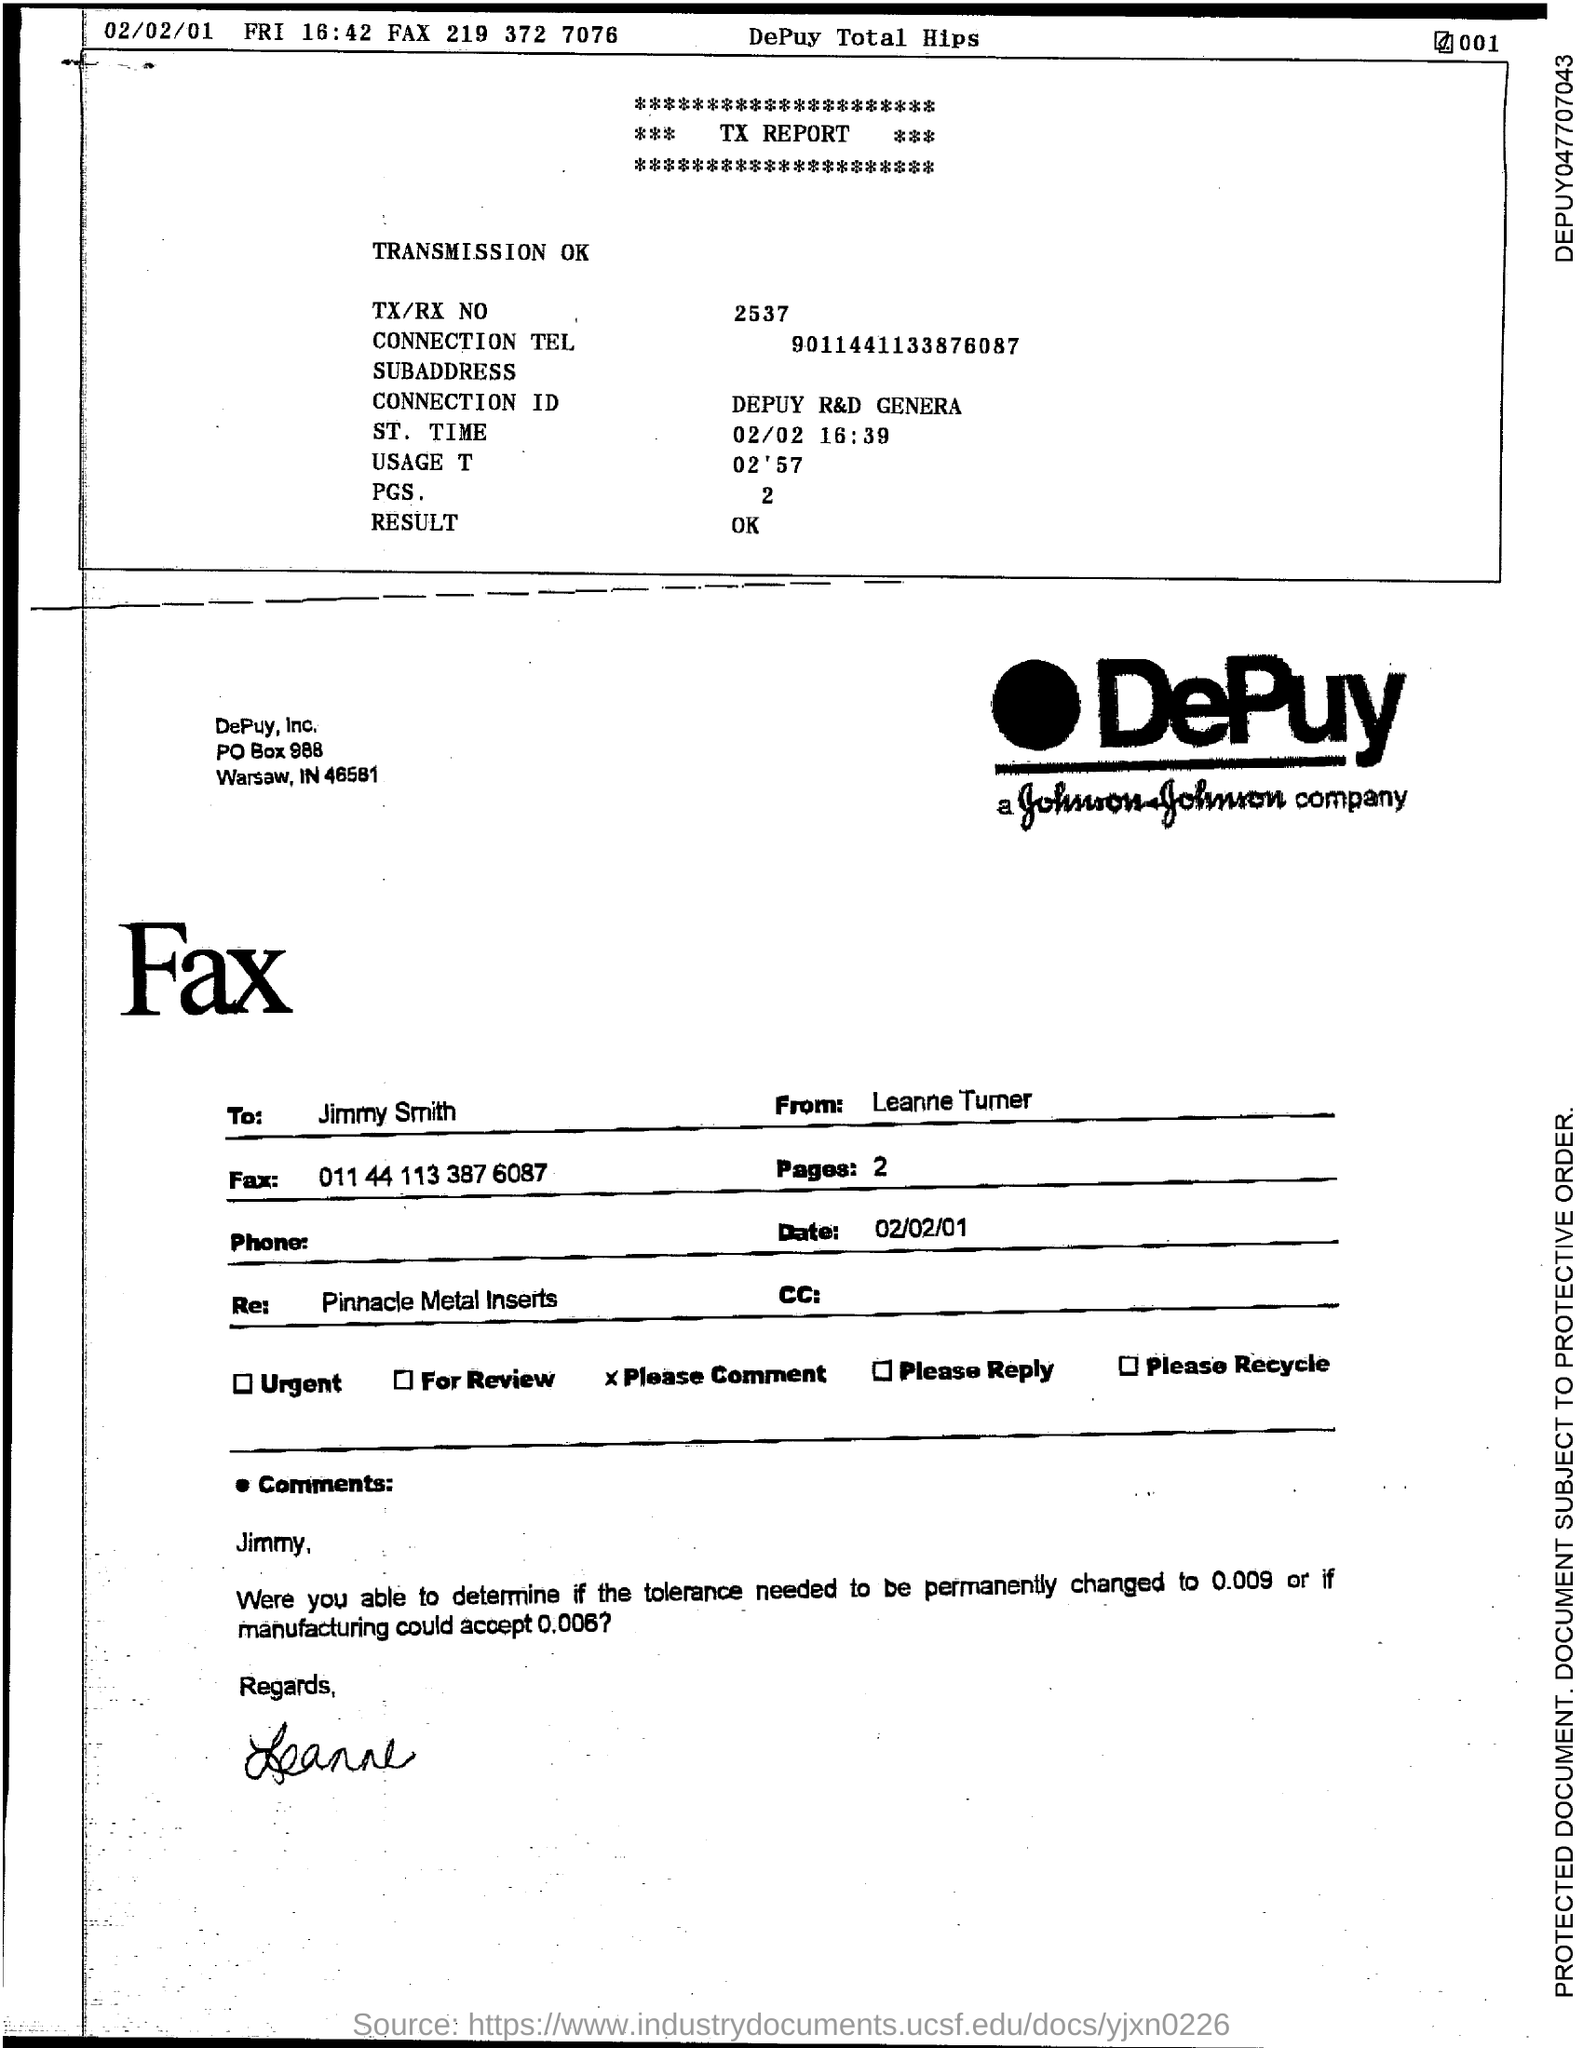Draw attention to some important aspects in this diagram. The PGS is a type of genetic testing that examines the entire genome, including non-coding regions and small variations, to identify genetic variations that may be associated with increased risk for certain diseases or conditions. The St. Time is 02/02 16:39. The fax is from Leanne Turner. The fax is addressed to Jimmy Smith. The connection ID refers to a specific code or identifier that is associated with a particular connection or link between two or more devices, systems, or components. In the context of Depuy R&D Generating a connection ID, it likely refers to the process of creating a unique code or identifier for a specific connection or link between two or more components or systems. 